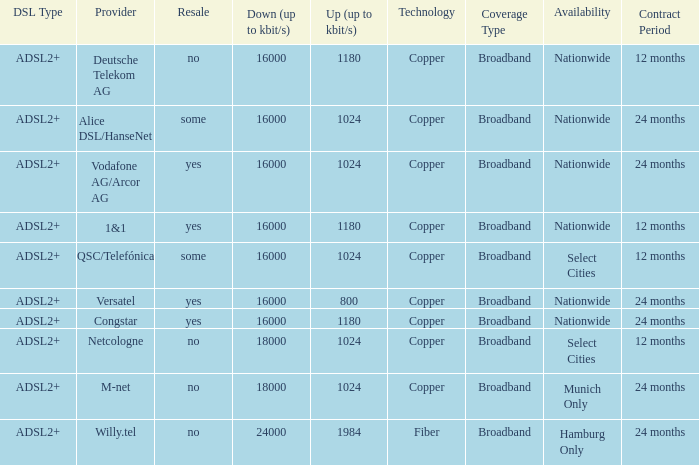What is the resale category for the provider NetCologne? No. 